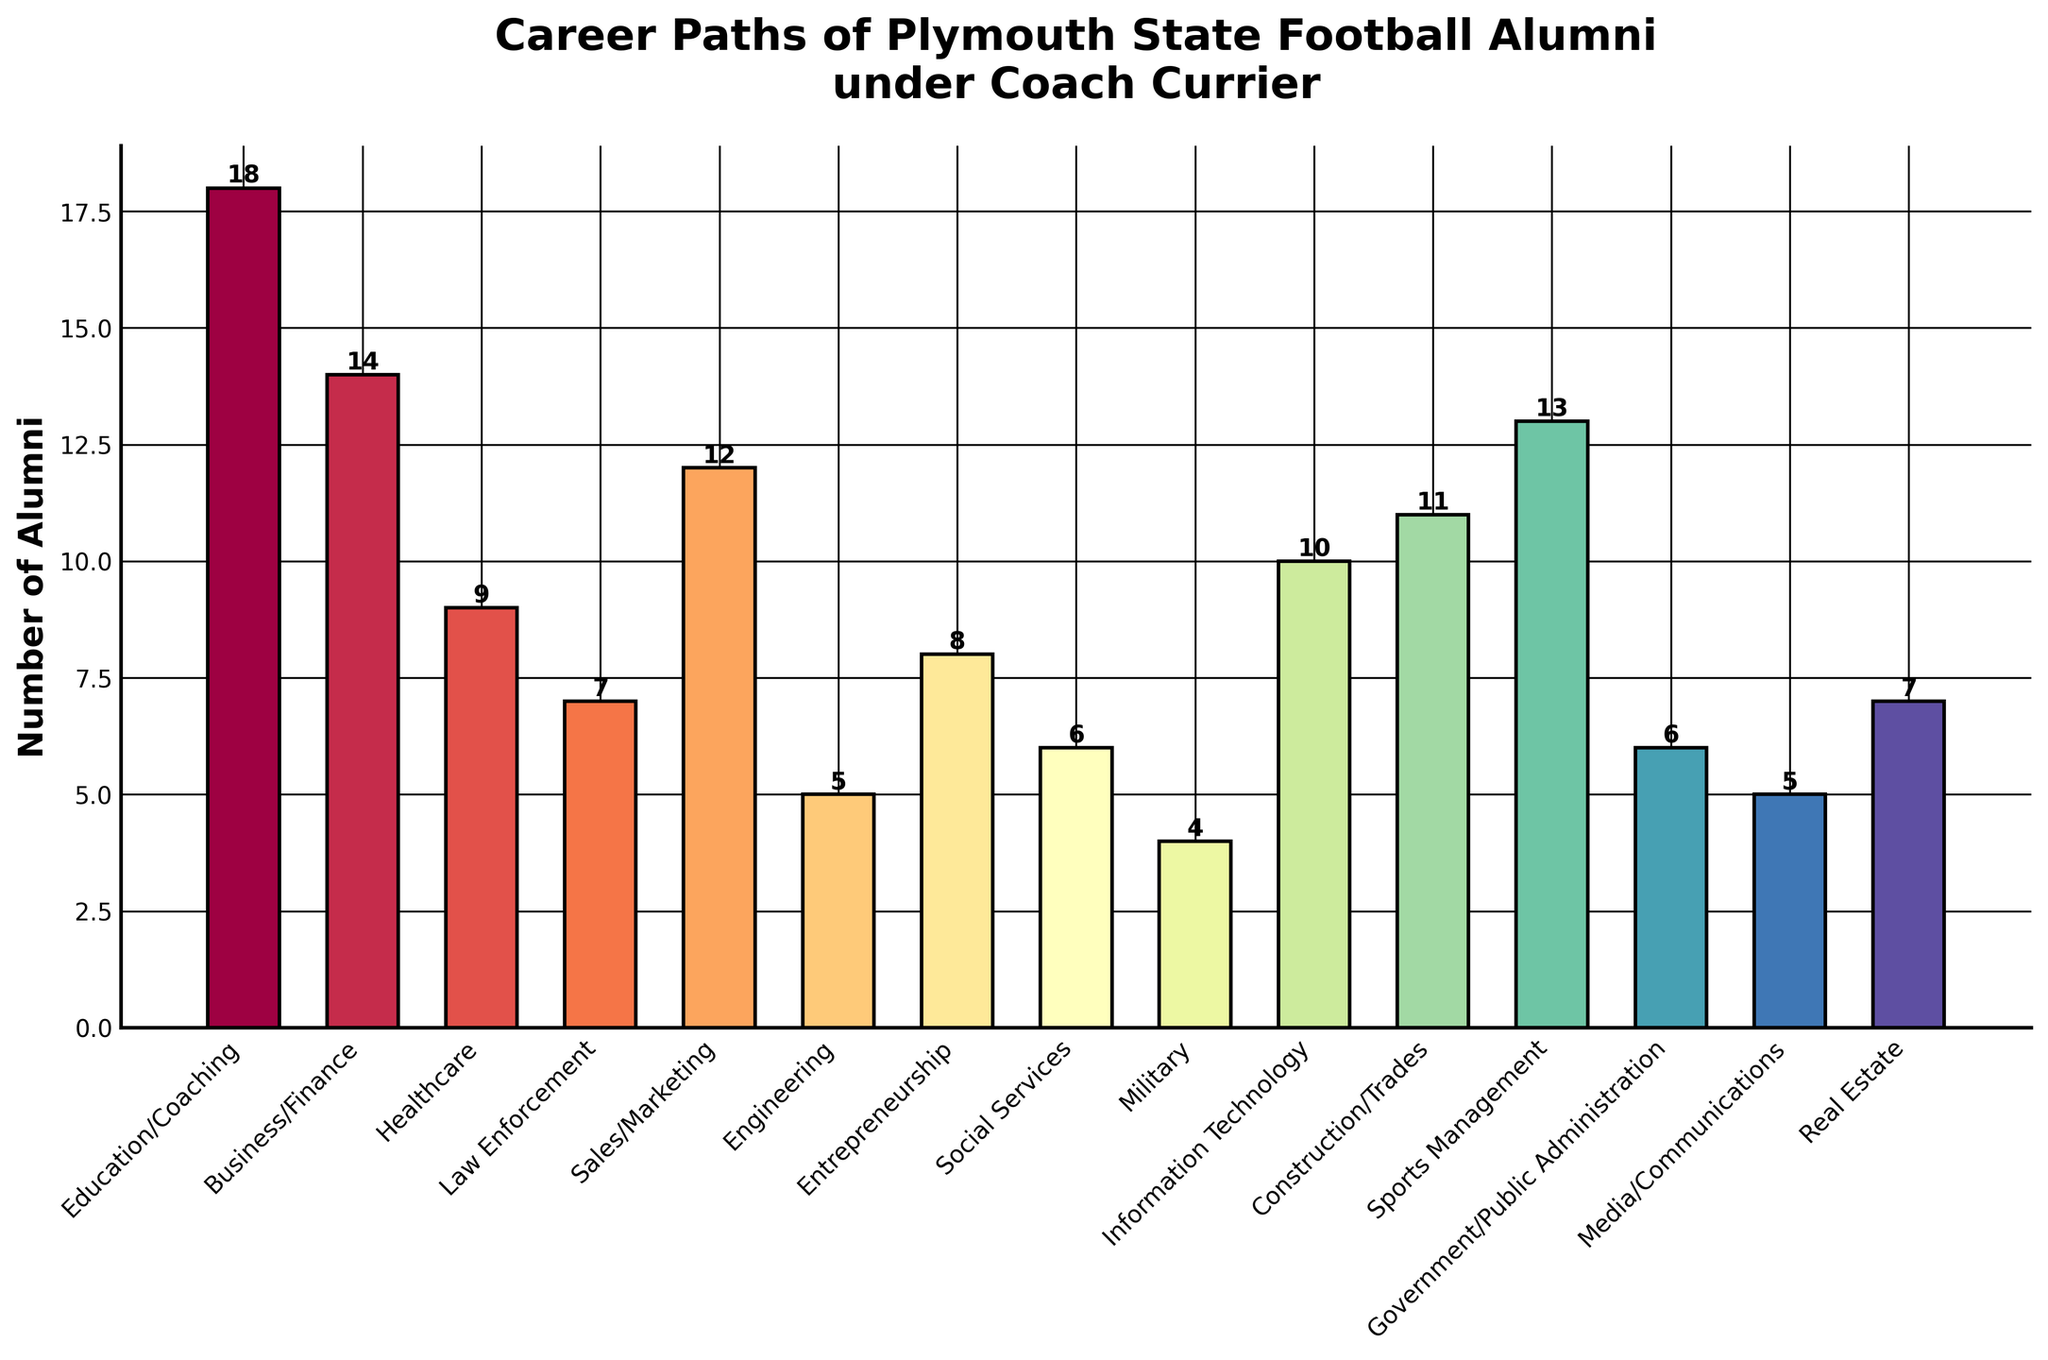Which career path has the highest number of alumni? The height of each bar represents the number of alumni in each career path. The tallest bar is for "Education/Coaching" with 18 alumni.
Answer: Education/Coaching How many alumni pursued careers in Sales/Marketing and Business/Finance combined? By looking at the heights of the bars for "Sales/Marketing" and "Business/Finance", we can sum their values: 12 (Sales/Marketing) + 14 (Business/Finance) = 26.
Answer: 26 Which career paths have exactly 5 alumni? Checking the heights of the bars, we find that "Engineering" and "Media/Communications" both have bars with a height of 5.
Answer: Engineering and Media/Communications Is the number of alumni in Healthcare greater than in Social Services? The height of the bar for "Healthcare" is higher than that for "Social Services": Healthcare has 9 alumni and Social Services has 6.
Answer: Yes What is the difference in the number of alumni between Sports Management and Real Estate? The height of the "Sports Management" bar is 13 and the height of the "Real Estate" bar is 7. The difference is 13 - 7 = 6.
Answer: 6 What's the average number of alumni across all career paths? Sum all the bar heights and divide by the number of categories: (18+14+9+7+12+5+8+6+4+10+11+13+6+5+7) / 15 = 135 / 15 = 9.
Answer: 9 Are there more alumni in Information Technology or in Construction/Trades? Comparing the heights of the two bars, Information Technology has 10 alumni, while Construction/Trades has 11.
Answer: Construction/Trades What percentage of the alumni have pursued careers in Law Enforcement? There are 7 alumni in Law Enforcement out of a total of 135 (sum of all the bar heights): (7/135) * 100 ≈ 5.19%.
Answer: ≈ 5.19% Which career path has the second lowest number of alumni? The career path with the lowest number is "Military" with 4 alumni. The second lowest is a tie between "Engineering" and "Media/Communications" with 5 alumni each.
Answer: Engineering and Media/Communications How many more alumni are in Education/Coaching compared to Entrepreneurship? The height of the "Education/Coaching" bar is 18 and the height of the "Entrepreneurship" bar is 8. The difference is 18 - 8 = 10.
Answer: 10 